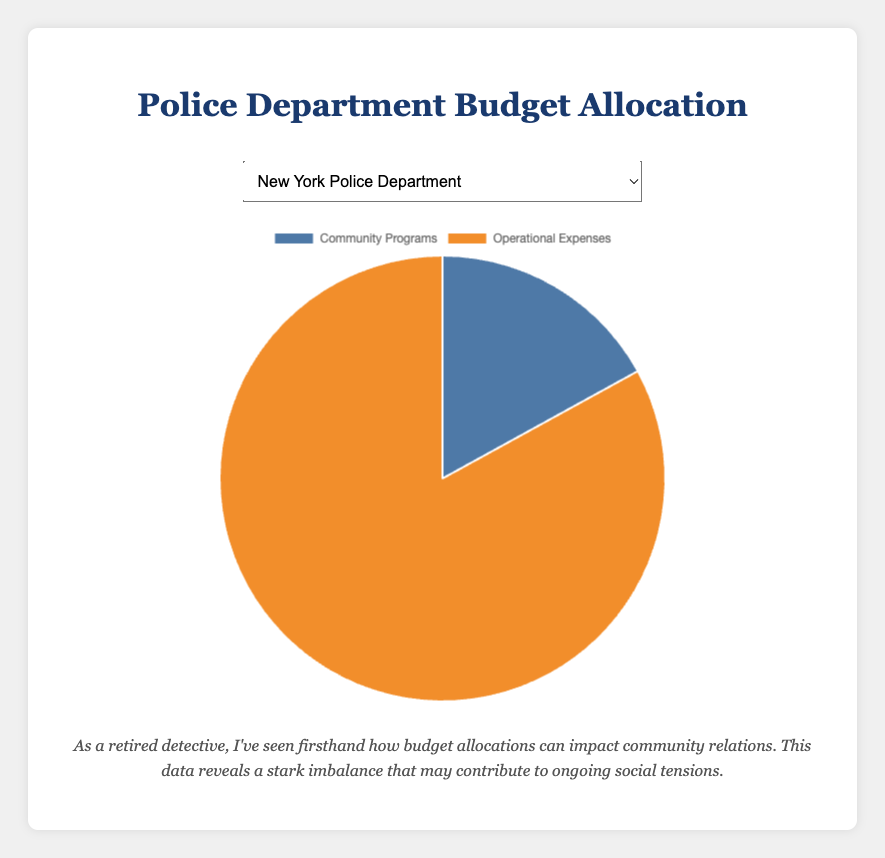What percentage of the New York Police Department's budget is allocated to community programs compared to operational expenses? To determine the percentage, look at the data points: community programs have 17% and operational expenses have 83%.
Answer: 17% Which police department allocates the highest percentage of its budget to community programs? Review the pie chart percentages for each department's allocation to community programs: NYPD (17%), LAPD (20%), Chicago (22%), Houston (15%), Phoenix (18%), Philadelphia (19%).
Answer: Chicago Police Department What is the difference in budget allocation for community programs between Los Angeles and Houston Police Departments? The Los Angeles Police Department allocates 20% to community programs, whereas Houston allocates 15%. To find the difference, subtract Houston's percentage from Los Angeles's: 20% - 15% = 5%.
Answer: 5% Which police department allocates a greater portion of its budget to operational expenses, Phoenix or Philadelphia? Compare the operational expenses: Phoenix Police Department allocates 82%, and Philadelphia Police Department allocates 81%.
Answer: Phoenix Police Department What is the average percentage allocation to community programs across all listed police departments? Calculate the average by summing the community programs percentages (17% + 20% + 22% + 15% + 18% + 19%) and then dividing by the number of departments (6). So, (17 + 20 + 22 + 15 + 18 + 19) / 6 = 18.5%.
Answer: 18.5% If you combined the budgets of New York and Phoenix Police Departments, what percentage of the total would be allocated to operational expenses? First, sum their operational expenses: NYPD (83%) and Phoenix (82%), which is 83% + 82% = 165%. Divide by 2 departments to get the average: 165% / 2 = 82.5%.
Answer: 82.5% Compare the visual representation of the pie charts for New York and Los Angeles Police Departments. Which has a larger slice for community programs? By visually comparing the slices represented for community programs, the Los Angeles Police Department has a larger slice (20%) than New York (17%).
Answer: Los Angeles Police Department Is there any department with an equal distribution between community programs and operational expenses? Reviewing the data, none of the departments listed have an equal 50-50 split; they all allocate a larger portion to operational expenses.
Answer: No Which department's pie chart has the smallest slice for community programs allocation? Visually compare the smallest slice for community programs: it's the Houston Police Department with 15%.
Answer: Houston Police Department What is the combined percentage of budgets allocated to community programs for Chicago, Houston, and Philadelphia Police Departments? Add the percentages for community programs: Chicago (22%), Houston (15%), and Philadelphia (19%). Sum them up: 22% + 15% + 19% = 56%.
Answer: 56% 